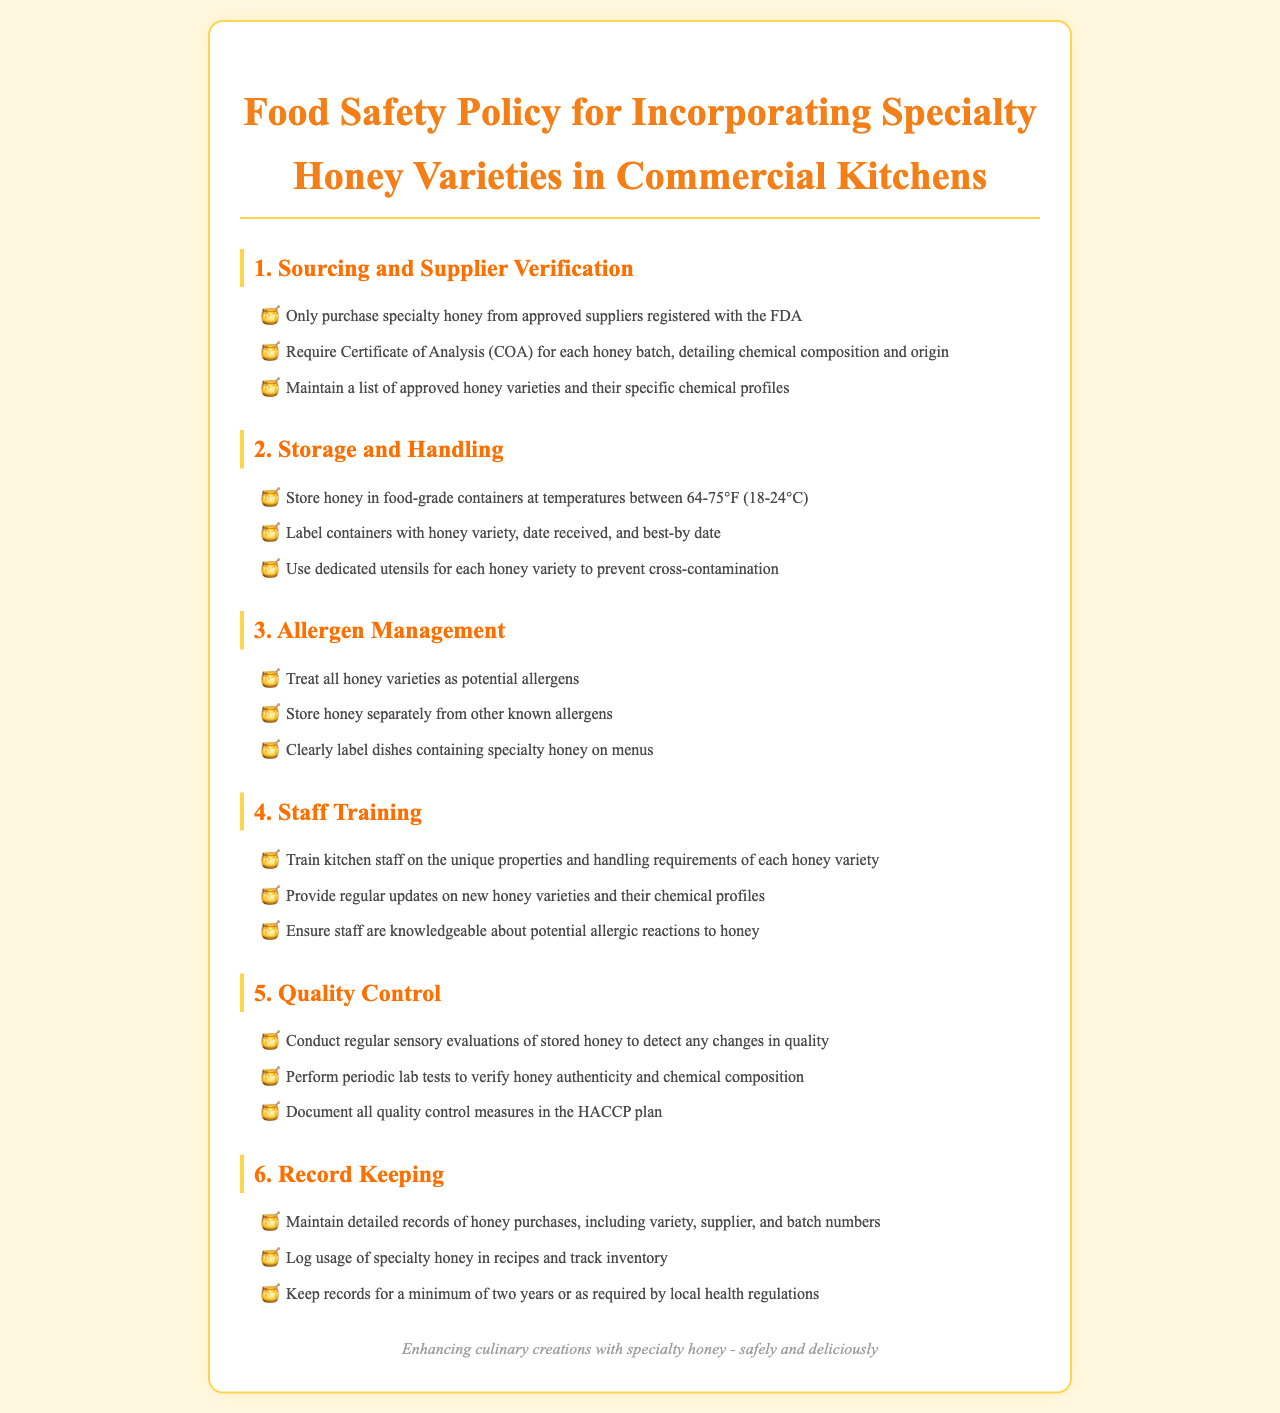What is required for each honey batch? Each honey batch requires a Certificate of Analysis detailing chemical composition and origin.
Answer: Certificate of Analysis What temperature should honey be stored at? Honey should be stored between 64-75°F (18-24°C).
Answer: 64-75°F How should honey containers be labeled? Honey containers should be labeled with the variety, date received, and best-by date.
Answer: Variety, date received, best-by date How long should records be kept? Records should be maintained for a minimum of two years or as required by local health regulations.
Answer: Two years What should staff be trained on regarding honey? Staff should be trained on the unique properties and handling requirements of each honey variety.
Answer: Unique properties and handling requirements Why is allergen management important for honey? Allergen management is important because all honey varieties are treated as potential allergens.
Answer: Potential allergens What is the purpose of regular sensory evaluations? The purpose is to detect any changes in quality of stored honey.
Answer: Detect changes in quality Which plan should document quality control measures? Quality control measures should be documented in the HACCP plan.
Answer: HACCP plan 